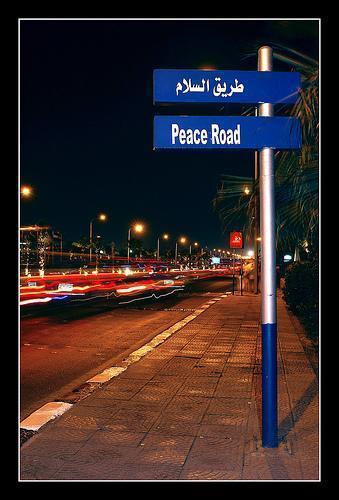How many languages are used in the signs?
Give a very brief answer. 2. 